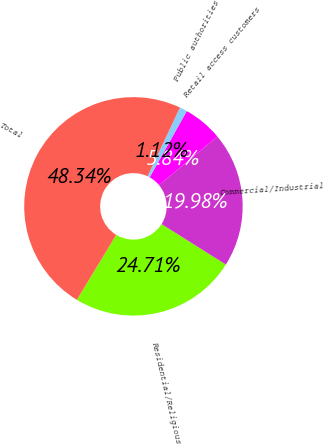Convert chart. <chart><loc_0><loc_0><loc_500><loc_500><pie_chart><fcel>Residential/Religious<fcel>Commercial/Industrial<fcel>Retail access customers<fcel>Public authorities<fcel>Total<nl><fcel>24.71%<fcel>19.98%<fcel>5.84%<fcel>1.12%<fcel>48.34%<nl></chart> 